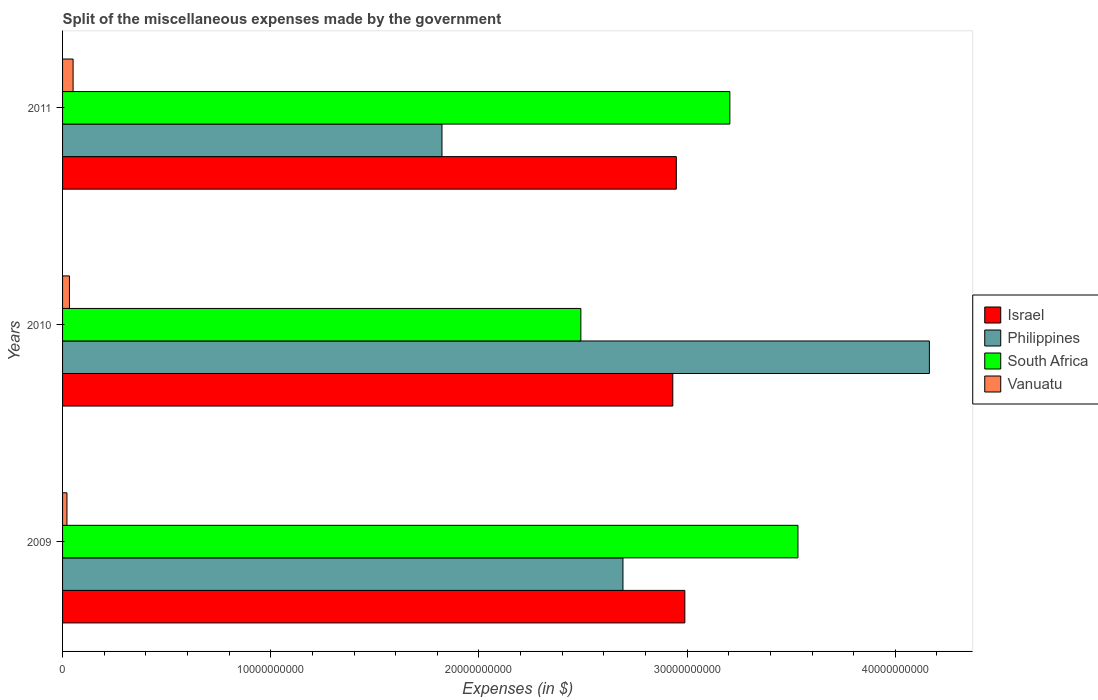How many different coloured bars are there?
Keep it short and to the point. 4. Are the number of bars per tick equal to the number of legend labels?
Offer a terse response. Yes. How many bars are there on the 1st tick from the top?
Your answer should be compact. 4. How many bars are there on the 3rd tick from the bottom?
Ensure brevity in your answer.  4. What is the miscellaneous expenses made by the government in Israel in 2010?
Your response must be concise. 2.93e+1. Across all years, what is the maximum miscellaneous expenses made by the government in Israel?
Offer a very short reply. 2.99e+1. Across all years, what is the minimum miscellaneous expenses made by the government in South Africa?
Keep it short and to the point. 2.49e+1. What is the total miscellaneous expenses made by the government in Vanuatu in the graph?
Keep it short and to the point. 1.05e+09. What is the difference between the miscellaneous expenses made by the government in Philippines in 2010 and that in 2011?
Offer a terse response. 2.34e+1. What is the difference between the miscellaneous expenses made by the government in Vanuatu in 2010 and the miscellaneous expenses made by the government in Philippines in 2011?
Offer a terse response. -1.79e+1. What is the average miscellaneous expenses made by the government in South Africa per year?
Your response must be concise. 3.08e+1. In the year 2009, what is the difference between the miscellaneous expenses made by the government in Vanuatu and miscellaneous expenses made by the government in South Africa?
Your response must be concise. -3.51e+1. In how many years, is the miscellaneous expenses made by the government in South Africa greater than 32000000000 $?
Your response must be concise. 2. What is the ratio of the miscellaneous expenses made by the government in South Africa in 2010 to that in 2011?
Offer a very short reply. 0.78. Is the miscellaneous expenses made by the government in South Africa in 2010 less than that in 2011?
Offer a terse response. Yes. What is the difference between the highest and the second highest miscellaneous expenses made by the government in Philippines?
Your answer should be very brief. 1.47e+1. What is the difference between the highest and the lowest miscellaneous expenses made by the government in Vanuatu?
Make the answer very short. 2.95e+08. In how many years, is the miscellaneous expenses made by the government in Philippines greater than the average miscellaneous expenses made by the government in Philippines taken over all years?
Offer a very short reply. 1. Is the sum of the miscellaneous expenses made by the government in Philippines in 2010 and 2011 greater than the maximum miscellaneous expenses made by the government in Israel across all years?
Your answer should be very brief. Yes. Is it the case that in every year, the sum of the miscellaneous expenses made by the government in Israel and miscellaneous expenses made by the government in Philippines is greater than the sum of miscellaneous expenses made by the government in Vanuatu and miscellaneous expenses made by the government in South Africa?
Your response must be concise. No. What does the 1st bar from the top in 2011 represents?
Offer a terse response. Vanuatu. What does the 2nd bar from the bottom in 2011 represents?
Provide a short and direct response. Philippines. How many bars are there?
Your answer should be very brief. 12. What is the difference between two consecutive major ticks on the X-axis?
Make the answer very short. 1.00e+1. Does the graph contain grids?
Your answer should be compact. No. How many legend labels are there?
Your response must be concise. 4. What is the title of the graph?
Your response must be concise. Split of the miscellaneous expenses made by the government. What is the label or title of the X-axis?
Your answer should be very brief. Expenses (in $). What is the Expenses (in $) in Israel in 2009?
Provide a short and direct response. 2.99e+1. What is the Expenses (in $) of Philippines in 2009?
Keep it short and to the point. 2.69e+1. What is the Expenses (in $) of South Africa in 2009?
Make the answer very short. 3.53e+1. What is the Expenses (in $) in Vanuatu in 2009?
Provide a short and direct response. 2.11e+08. What is the Expenses (in $) in Israel in 2010?
Provide a short and direct response. 2.93e+1. What is the Expenses (in $) in Philippines in 2010?
Your answer should be very brief. 4.16e+1. What is the Expenses (in $) of South Africa in 2010?
Your answer should be compact. 2.49e+1. What is the Expenses (in $) in Vanuatu in 2010?
Keep it short and to the point. 3.31e+08. What is the Expenses (in $) in Israel in 2011?
Make the answer very short. 2.95e+1. What is the Expenses (in $) in Philippines in 2011?
Your answer should be very brief. 1.82e+1. What is the Expenses (in $) in South Africa in 2011?
Provide a succinct answer. 3.21e+1. What is the Expenses (in $) of Vanuatu in 2011?
Keep it short and to the point. 5.06e+08. Across all years, what is the maximum Expenses (in $) of Israel?
Give a very brief answer. 2.99e+1. Across all years, what is the maximum Expenses (in $) of Philippines?
Your answer should be very brief. 4.16e+1. Across all years, what is the maximum Expenses (in $) in South Africa?
Your response must be concise. 3.53e+1. Across all years, what is the maximum Expenses (in $) in Vanuatu?
Provide a short and direct response. 5.06e+08. Across all years, what is the minimum Expenses (in $) in Israel?
Keep it short and to the point. 2.93e+1. Across all years, what is the minimum Expenses (in $) in Philippines?
Your answer should be compact. 1.82e+1. Across all years, what is the minimum Expenses (in $) of South Africa?
Your answer should be compact. 2.49e+1. Across all years, what is the minimum Expenses (in $) in Vanuatu?
Your response must be concise. 2.11e+08. What is the total Expenses (in $) in Israel in the graph?
Make the answer very short. 8.87e+1. What is the total Expenses (in $) of Philippines in the graph?
Offer a very short reply. 8.68e+1. What is the total Expenses (in $) of South Africa in the graph?
Offer a terse response. 9.23e+1. What is the total Expenses (in $) of Vanuatu in the graph?
Your answer should be compact. 1.05e+09. What is the difference between the Expenses (in $) of Israel in 2009 and that in 2010?
Give a very brief answer. 5.78e+08. What is the difference between the Expenses (in $) in Philippines in 2009 and that in 2010?
Your response must be concise. -1.47e+1. What is the difference between the Expenses (in $) in South Africa in 2009 and that in 2010?
Keep it short and to the point. 1.04e+1. What is the difference between the Expenses (in $) of Vanuatu in 2009 and that in 2010?
Make the answer very short. -1.20e+08. What is the difference between the Expenses (in $) in Israel in 2009 and that in 2011?
Make the answer very short. 4.09e+08. What is the difference between the Expenses (in $) of Philippines in 2009 and that in 2011?
Your answer should be very brief. 8.69e+09. What is the difference between the Expenses (in $) in South Africa in 2009 and that in 2011?
Provide a succinct answer. 3.27e+09. What is the difference between the Expenses (in $) in Vanuatu in 2009 and that in 2011?
Provide a short and direct response. -2.95e+08. What is the difference between the Expenses (in $) in Israel in 2010 and that in 2011?
Your response must be concise. -1.70e+08. What is the difference between the Expenses (in $) of Philippines in 2010 and that in 2011?
Give a very brief answer. 2.34e+1. What is the difference between the Expenses (in $) of South Africa in 2010 and that in 2011?
Give a very brief answer. -7.16e+09. What is the difference between the Expenses (in $) in Vanuatu in 2010 and that in 2011?
Give a very brief answer. -1.75e+08. What is the difference between the Expenses (in $) in Israel in 2009 and the Expenses (in $) in Philippines in 2010?
Your answer should be very brief. -1.17e+1. What is the difference between the Expenses (in $) of Israel in 2009 and the Expenses (in $) of South Africa in 2010?
Ensure brevity in your answer.  4.99e+09. What is the difference between the Expenses (in $) in Israel in 2009 and the Expenses (in $) in Vanuatu in 2010?
Your response must be concise. 2.96e+1. What is the difference between the Expenses (in $) in Philippines in 2009 and the Expenses (in $) in South Africa in 2010?
Ensure brevity in your answer.  2.02e+09. What is the difference between the Expenses (in $) in Philippines in 2009 and the Expenses (in $) in Vanuatu in 2010?
Your response must be concise. 2.66e+1. What is the difference between the Expenses (in $) of South Africa in 2009 and the Expenses (in $) of Vanuatu in 2010?
Provide a short and direct response. 3.50e+1. What is the difference between the Expenses (in $) in Israel in 2009 and the Expenses (in $) in Philippines in 2011?
Your answer should be compact. 1.17e+1. What is the difference between the Expenses (in $) in Israel in 2009 and the Expenses (in $) in South Africa in 2011?
Your response must be concise. -2.16e+09. What is the difference between the Expenses (in $) of Israel in 2009 and the Expenses (in $) of Vanuatu in 2011?
Keep it short and to the point. 2.94e+1. What is the difference between the Expenses (in $) of Philippines in 2009 and the Expenses (in $) of South Africa in 2011?
Offer a very short reply. -5.13e+09. What is the difference between the Expenses (in $) in Philippines in 2009 and the Expenses (in $) in Vanuatu in 2011?
Provide a succinct answer. 2.64e+1. What is the difference between the Expenses (in $) in South Africa in 2009 and the Expenses (in $) in Vanuatu in 2011?
Your answer should be compact. 3.48e+1. What is the difference between the Expenses (in $) of Israel in 2010 and the Expenses (in $) of Philippines in 2011?
Your answer should be compact. 1.11e+1. What is the difference between the Expenses (in $) in Israel in 2010 and the Expenses (in $) in South Africa in 2011?
Provide a succinct answer. -2.74e+09. What is the difference between the Expenses (in $) in Israel in 2010 and the Expenses (in $) in Vanuatu in 2011?
Keep it short and to the point. 2.88e+1. What is the difference between the Expenses (in $) of Philippines in 2010 and the Expenses (in $) of South Africa in 2011?
Offer a terse response. 9.58e+09. What is the difference between the Expenses (in $) of Philippines in 2010 and the Expenses (in $) of Vanuatu in 2011?
Provide a short and direct response. 4.11e+1. What is the difference between the Expenses (in $) in South Africa in 2010 and the Expenses (in $) in Vanuatu in 2011?
Your response must be concise. 2.44e+1. What is the average Expenses (in $) in Israel per year?
Your response must be concise. 2.96e+1. What is the average Expenses (in $) in Philippines per year?
Make the answer very short. 2.89e+1. What is the average Expenses (in $) of South Africa per year?
Offer a very short reply. 3.08e+1. What is the average Expenses (in $) in Vanuatu per year?
Your answer should be compact. 3.49e+08. In the year 2009, what is the difference between the Expenses (in $) in Israel and Expenses (in $) in Philippines?
Make the answer very short. 2.97e+09. In the year 2009, what is the difference between the Expenses (in $) of Israel and Expenses (in $) of South Africa?
Give a very brief answer. -5.43e+09. In the year 2009, what is the difference between the Expenses (in $) in Israel and Expenses (in $) in Vanuatu?
Your answer should be very brief. 2.97e+1. In the year 2009, what is the difference between the Expenses (in $) of Philippines and Expenses (in $) of South Africa?
Keep it short and to the point. -8.41e+09. In the year 2009, what is the difference between the Expenses (in $) in Philippines and Expenses (in $) in Vanuatu?
Your answer should be compact. 2.67e+1. In the year 2009, what is the difference between the Expenses (in $) in South Africa and Expenses (in $) in Vanuatu?
Your response must be concise. 3.51e+1. In the year 2010, what is the difference between the Expenses (in $) of Israel and Expenses (in $) of Philippines?
Keep it short and to the point. -1.23e+1. In the year 2010, what is the difference between the Expenses (in $) of Israel and Expenses (in $) of South Africa?
Your answer should be very brief. 4.42e+09. In the year 2010, what is the difference between the Expenses (in $) of Israel and Expenses (in $) of Vanuatu?
Provide a short and direct response. 2.90e+1. In the year 2010, what is the difference between the Expenses (in $) of Philippines and Expenses (in $) of South Africa?
Your response must be concise. 1.67e+1. In the year 2010, what is the difference between the Expenses (in $) of Philippines and Expenses (in $) of Vanuatu?
Keep it short and to the point. 4.13e+1. In the year 2010, what is the difference between the Expenses (in $) in South Africa and Expenses (in $) in Vanuatu?
Your answer should be very brief. 2.46e+1. In the year 2011, what is the difference between the Expenses (in $) of Israel and Expenses (in $) of Philippines?
Offer a very short reply. 1.13e+1. In the year 2011, what is the difference between the Expenses (in $) in Israel and Expenses (in $) in South Africa?
Give a very brief answer. -2.57e+09. In the year 2011, what is the difference between the Expenses (in $) in Israel and Expenses (in $) in Vanuatu?
Provide a short and direct response. 2.90e+1. In the year 2011, what is the difference between the Expenses (in $) in Philippines and Expenses (in $) in South Africa?
Your response must be concise. -1.38e+1. In the year 2011, what is the difference between the Expenses (in $) of Philippines and Expenses (in $) of Vanuatu?
Make the answer very short. 1.77e+1. In the year 2011, what is the difference between the Expenses (in $) in South Africa and Expenses (in $) in Vanuatu?
Offer a very short reply. 3.15e+1. What is the ratio of the Expenses (in $) of Israel in 2009 to that in 2010?
Provide a short and direct response. 1.02. What is the ratio of the Expenses (in $) of Philippines in 2009 to that in 2010?
Give a very brief answer. 0.65. What is the ratio of the Expenses (in $) in South Africa in 2009 to that in 2010?
Your answer should be very brief. 1.42. What is the ratio of the Expenses (in $) in Vanuatu in 2009 to that in 2010?
Provide a succinct answer. 0.64. What is the ratio of the Expenses (in $) of Israel in 2009 to that in 2011?
Your answer should be very brief. 1.01. What is the ratio of the Expenses (in $) of Philippines in 2009 to that in 2011?
Ensure brevity in your answer.  1.48. What is the ratio of the Expenses (in $) of South Africa in 2009 to that in 2011?
Provide a short and direct response. 1.1. What is the ratio of the Expenses (in $) in Vanuatu in 2009 to that in 2011?
Offer a terse response. 0.42. What is the ratio of the Expenses (in $) of Israel in 2010 to that in 2011?
Offer a terse response. 0.99. What is the ratio of the Expenses (in $) of Philippines in 2010 to that in 2011?
Keep it short and to the point. 2.28. What is the ratio of the Expenses (in $) in South Africa in 2010 to that in 2011?
Keep it short and to the point. 0.78. What is the ratio of the Expenses (in $) in Vanuatu in 2010 to that in 2011?
Ensure brevity in your answer.  0.65. What is the difference between the highest and the second highest Expenses (in $) in Israel?
Provide a succinct answer. 4.09e+08. What is the difference between the highest and the second highest Expenses (in $) in Philippines?
Your response must be concise. 1.47e+1. What is the difference between the highest and the second highest Expenses (in $) of South Africa?
Keep it short and to the point. 3.27e+09. What is the difference between the highest and the second highest Expenses (in $) of Vanuatu?
Give a very brief answer. 1.75e+08. What is the difference between the highest and the lowest Expenses (in $) of Israel?
Ensure brevity in your answer.  5.78e+08. What is the difference between the highest and the lowest Expenses (in $) in Philippines?
Your answer should be compact. 2.34e+1. What is the difference between the highest and the lowest Expenses (in $) in South Africa?
Ensure brevity in your answer.  1.04e+1. What is the difference between the highest and the lowest Expenses (in $) in Vanuatu?
Provide a short and direct response. 2.95e+08. 